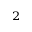Convert formula to latex. <formula><loc_0><loc_0><loc_500><loc_500>^ { 2 }</formula> 